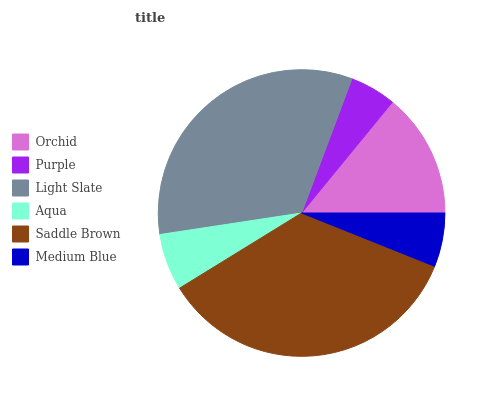Is Purple the minimum?
Answer yes or no. Yes. Is Saddle Brown the maximum?
Answer yes or no. Yes. Is Light Slate the minimum?
Answer yes or no. No. Is Light Slate the maximum?
Answer yes or no. No. Is Light Slate greater than Purple?
Answer yes or no. Yes. Is Purple less than Light Slate?
Answer yes or no. Yes. Is Purple greater than Light Slate?
Answer yes or no. No. Is Light Slate less than Purple?
Answer yes or no. No. Is Orchid the high median?
Answer yes or no. Yes. Is Aqua the low median?
Answer yes or no. Yes. Is Purple the high median?
Answer yes or no. No. Is Saddle Brown the low median?
Answer yes or no. No. 